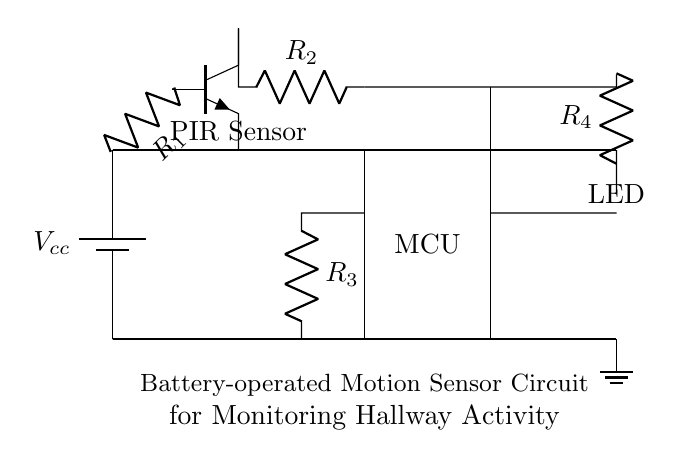What is the main power source for this circuit? The main power source is the battery, which is connected at the top left of the circuit and provides the necessary voltage for operation.
Answer: battery What type of sensor is used in the circuit? The circuit uses a PIR Sensor, which is indicated in the diagram as a key component for detecting motion.
Answer: PIR Sensor Which component indicates that motion has been detected? The LED acts as an indicator in the circuit, illuminating when the PIR sensor detects movement.
Answer: LED What is the function of the microcontroller in this circuit? The microcontroller processes the signals from the PIR sensor and decides when to activate the LED, contributing to the overall functionality of the motion detection system.
Answer: processes signals What is the purpose of resistor R4 in this circuit? Resistor R4 limits the current flowing to the LED, preventing it from burning out by ensuring proper voltage levels for operation.
Answer: current limiting How does the PIR sensor connect to the microcontroller? The PIR Sensor connects to the microcontroller through a resistor (R2) that allows the sensor's output signals to transmit correctly to the microcontroller for further action.
Answer: through R2 What type of circuit is this based on its primary function? This circuit is a motion detection circuit primarily designed to monitor hallway activity, utilizing low power components for efficiency.
Answer: motion detection circuit 